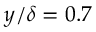<formula> <loc_0><loc_0><loc_500><loc_500>y / \delta = 0 . 7</formula> 